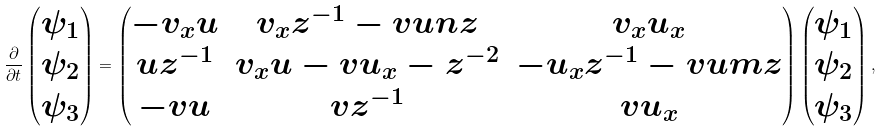Convert formula to latex. <formula><loc_0><loc_0><loc_500><loc_500>\frac { \partial } { \partial t } \begin{pmatrix} \psi _ { 1 } \\ \psi _ { 2 } \\ \psi _ { 3 } \end{pmatrix} = \begin{pmatrix} - v _ { x } u & v _ { x } z ^ { - 1 } - v u n z & v _ { x } u _ { x } \\ u z ^ { - 1 } & v _ { x } u - v u _ { x } - z ^ { - 2 } & - u _ { x } z ^ { - 1 } - v u m z \\ - v u & v z ^ { - 1 } & v u _ { x } \end{pmatrix} \begin{pmatrix} \psi _ { 1 } \\ \psi _ { 2 } \\ \psi _ { 3 } \end{pmatrix} ,</formula> 